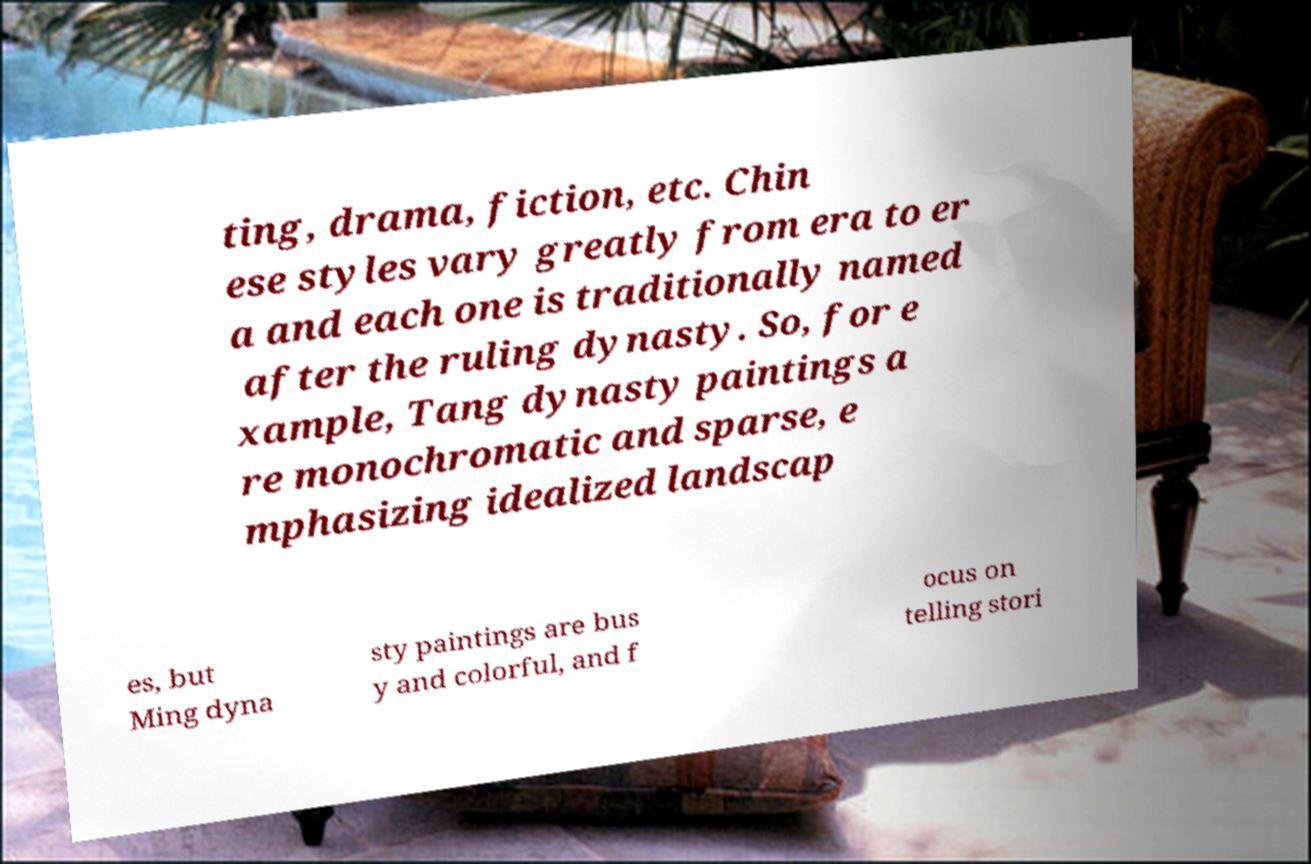Could you extract and type out the text from this image? ting, drama, fiction, etc. Chin ese styles vary greatly from era to er a and each one is traditionally named after the ruling dynasty. So, for e xample, Tang dynasty paintings a re monochromatic and sparse, e mphasizing idealized landscap es, but Ming dyna sty paintings are bus y and colorful, and f ocus on telling stori 